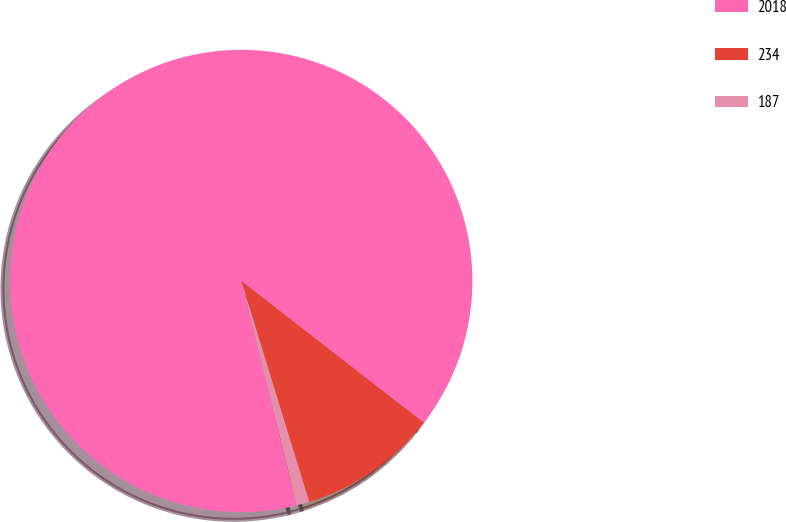Convert chart. <chart><loc_0><loc_0><loc_500><loc_500><pie_chart><fcel>2018<fcel>234<fcel>187<nl><fcel>89.37%<fcel>9.74%<fcel>0.89%<nl></chart> 